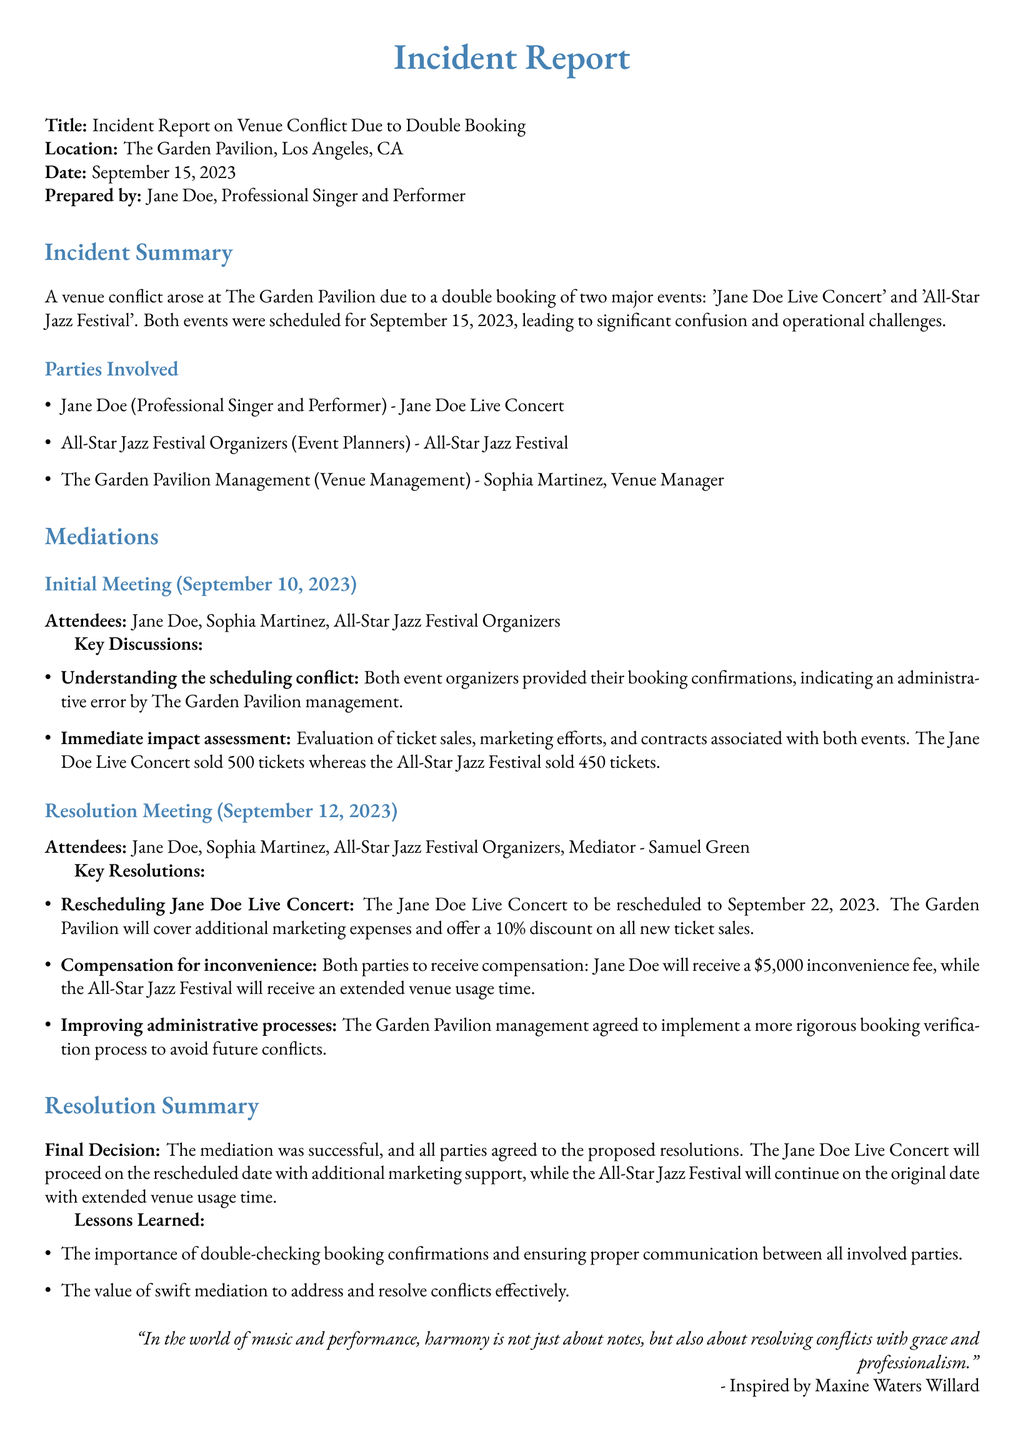What is the location of the incident? The incident occurred at The Garden Pavilion in Los Angeles, CA.
Answer: The Garden Pavilion, Los Angeles, CA Who prepared the incident report? The report was prepared by Jane Doe, who is a professional singer and performer.
Answer: Jane Doe When was the Jane Doe Live Concert originally scheduled? The concert was originally scheduled for September 15, 2023, as indicated in the report.
Answer: September 15, 2023 What was the inconvenience fee assigned to Jane Doe? The document states that Jane Doe will receive a $5,000 inconvenience fee due to the conflict.
Answer: $5,000 How many tickets were sold for the All-Star Jazz Festival? The report indicates that the All-Star Jazz Festival sold 450 tickets before the conflict.
Answer: 450 What date was the Jane Doe Live Concert rescheduled to? The concert was rescheduled to September 22, 2023, following the mediation discussions.
Answer: September 22, 2023 Who was the mediator involved in the resolution meeting? The resolution meeting included a mediator named Samuel Green.
Answer: Samuel Green What important lesson was learned from the conflict? One lesson emphasized the importance of double-checking booking confirmations to avoid similar conflicts in the future.
Answer: Double-checking booking confirmations 